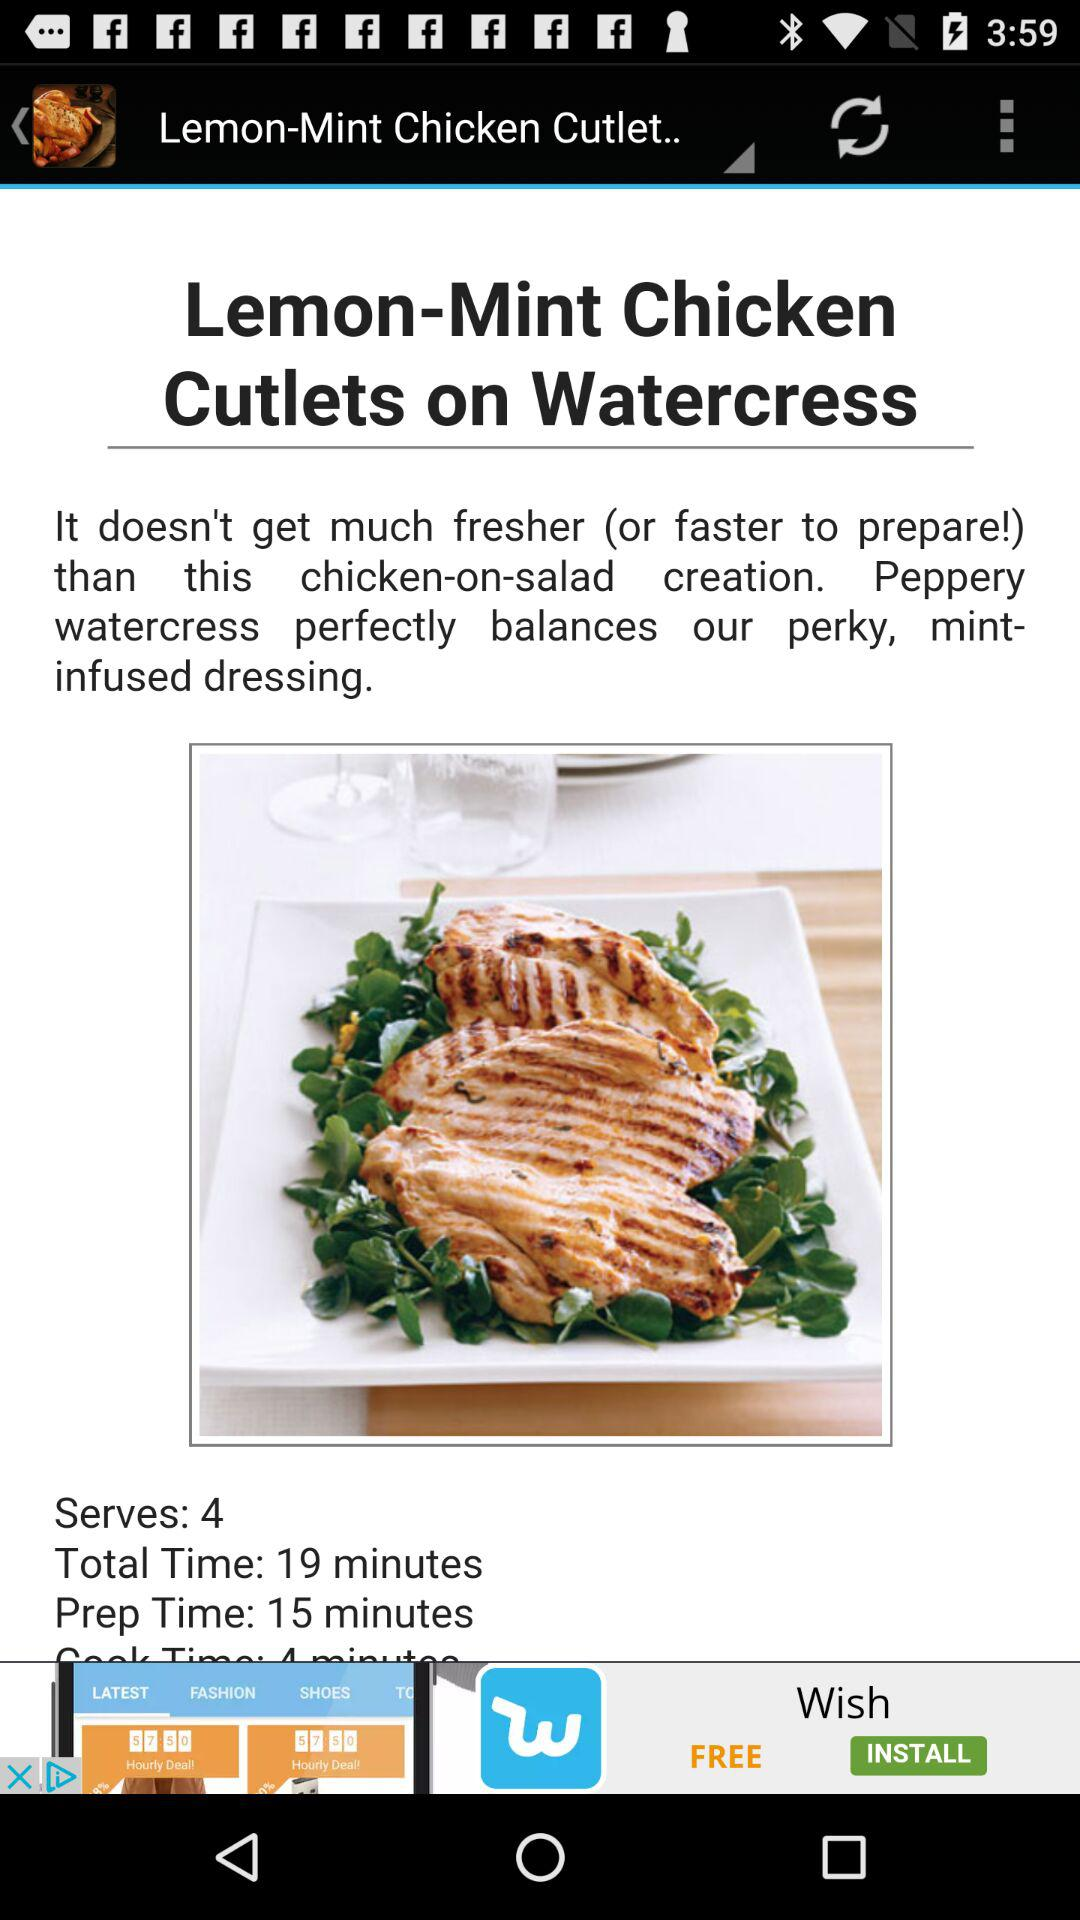What is the preparation time for the dish? The preparation time for the dish is 15 minutes. 